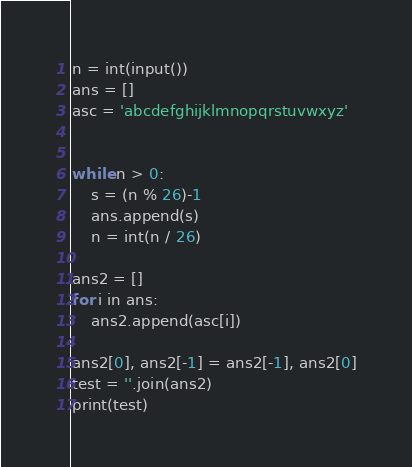Convert code to text. <code><loc_0><loc_0><loc_500><loc_500><_Python_>n = int(input())
ans = []
asc = 'abcdefghijklmnopqrstuvwxyz'


while n > 0:
    s = (n % 26)-1
    ans.append(s)
    n = int(n / 26)

ans2 = []
for i in ans:
    ans2.append(asc[i])

ans2[0], ans2[-1] = ans2[-1], ans2[0]
test = ''.join(ans2)
print(test)
</code> 